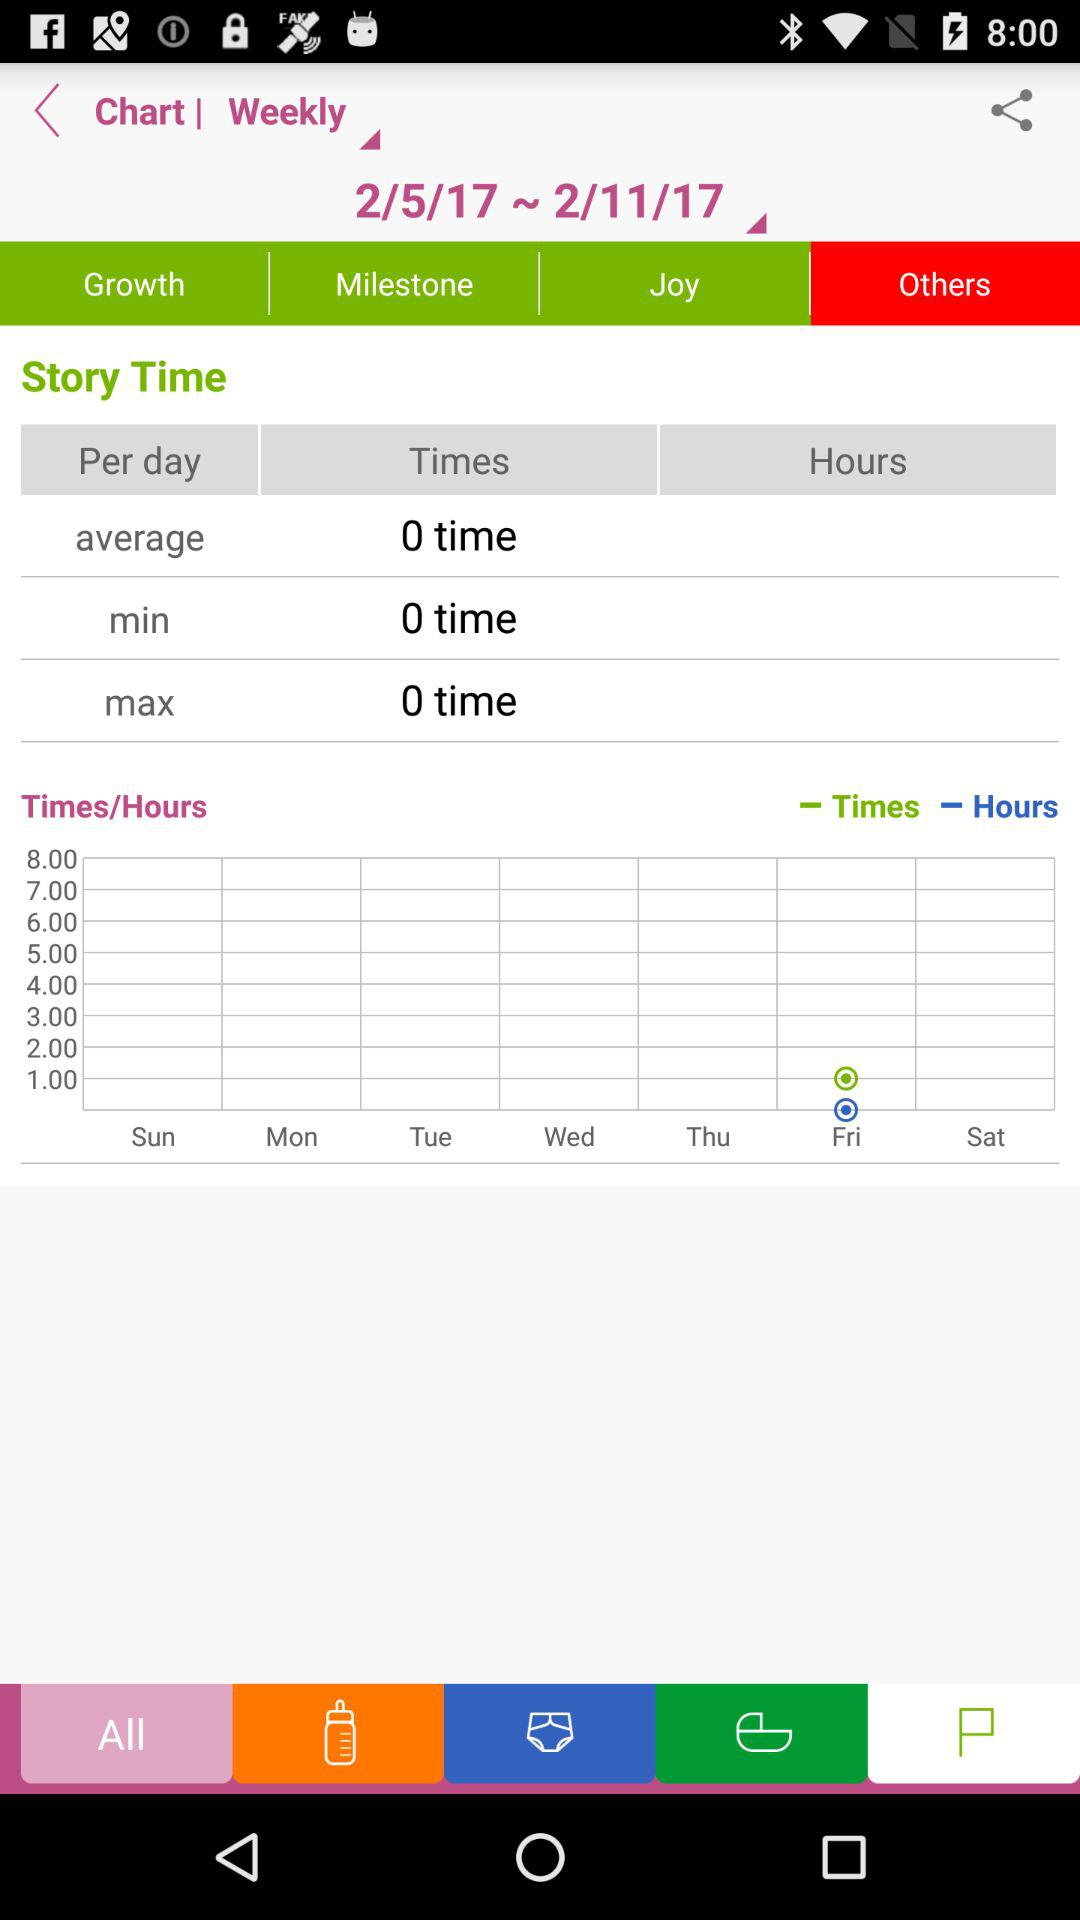What is the maximum time?
When the provided information is insufficient, respond with <no answer>. <no answer> 